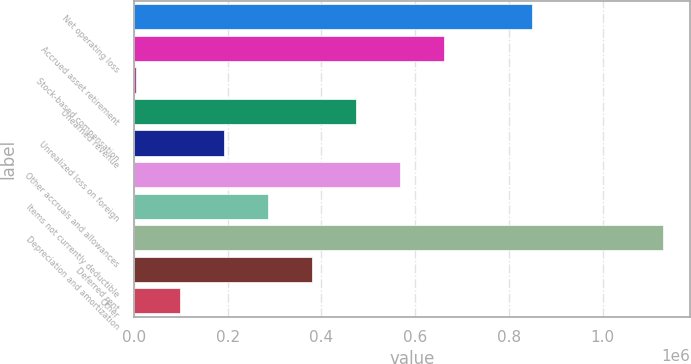<chart> <loc_0><loc_0><loc_500><loc_500><bar_chart><fcel>Net operating loss<fcel>Accrued asset retirement<fcel>Stock-based compensation<fcel>Unearned revenue<fcel>Unrealized loss on foreign<fcel>Other accruals and allowances<fcel>Items not currently deductible<fcel>Depreciation and amortization<fcel>Deferred rent<fcel>Other<nl><fcel>848595<fcel>660966<fcel>4267<fcel>473338<fcel>191895<fcel>567152<fcel>285710<fcel>1.13004e+06<fcel>379524<fcel>98081.2<nl></chart> 